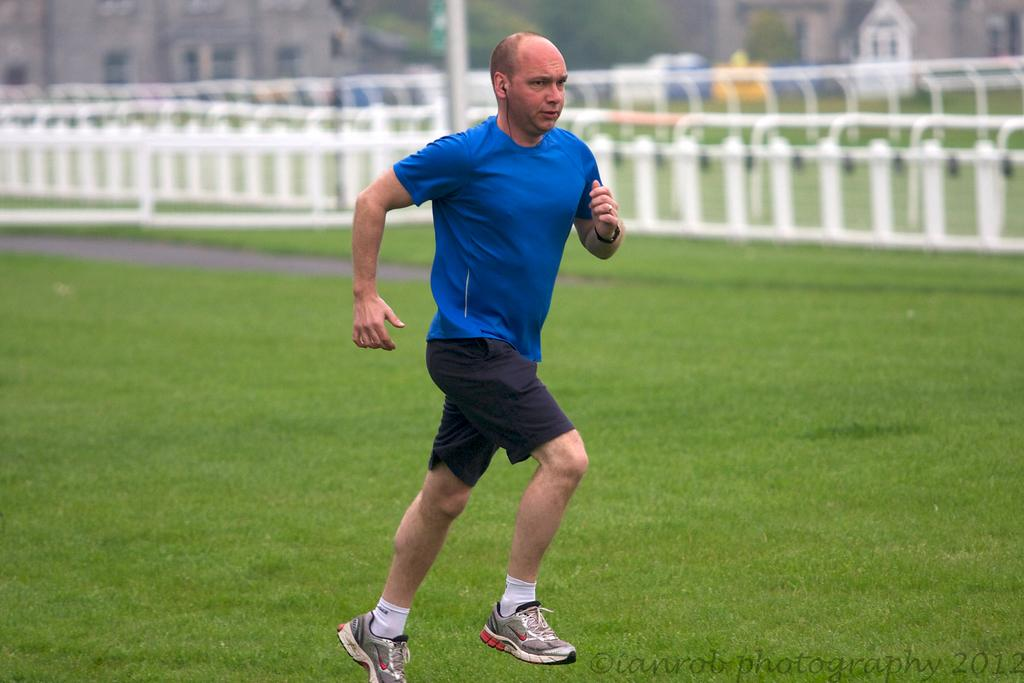Who is the main subject in the image? There is a man in the center of the image. What can be seen in the background of the image? There are railings, trees, and buildings in the background of the image. What is visible at the bottom of the image? There is ground visible at the bottom of the image. Is there any text present in the image? Yes, there is some text visible in the image. How many deer are visible in the image? There are no deer present in the image. Where is the sink located in the image? There is no sink present in the image. 